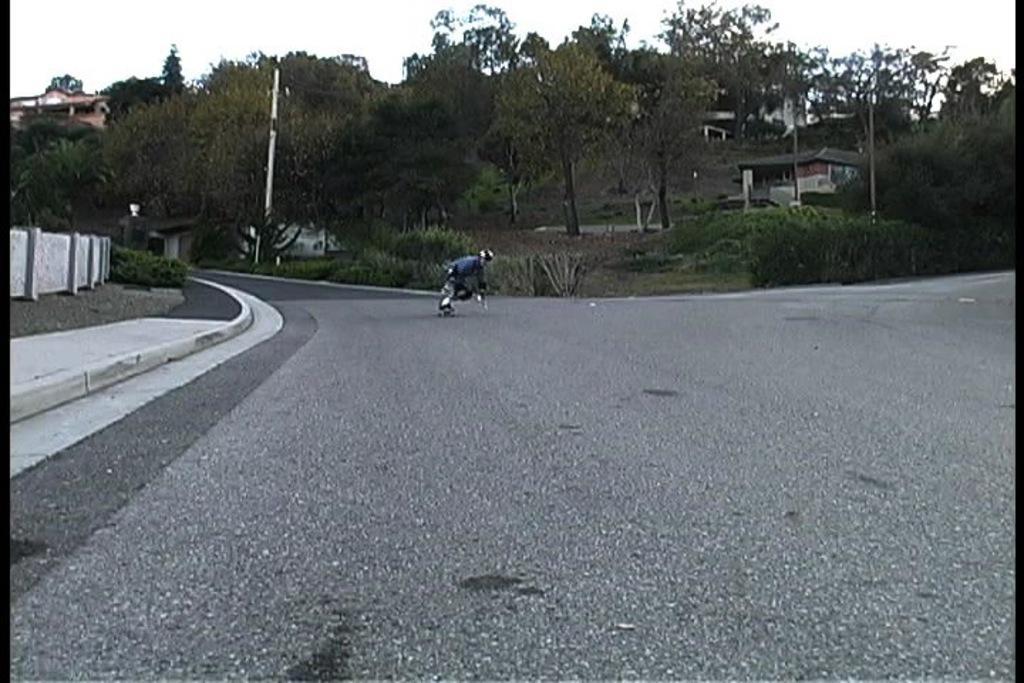Please provide a concise description of this image. In this image there is a person doing skating on the road, and there are poles, houses, trees, and in the background there is sky. 